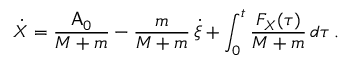Convert formula to latex. <formula><loc_0><loc_0><loc_500><loc_500>\dot { X } = \frac { A _ { 0 } } { M + m } - \frac { m } { M + m } \, \dot { \xi } + \int _ { 0 } ^ { t } \frac { F _ { X } ( \tau ) } { M + m } \, d \tau \, .</formula> 